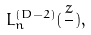<formula> <loc_0><loc_0><loc_500><loc_500>L _ { n } ^ { ( D - 2 ) } ( \frac { z } { } ) ,</formula> 